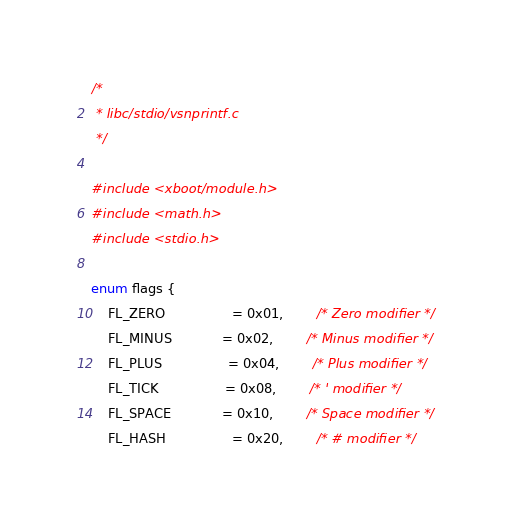<code> <loc_0><loc_0><loc_500><loc_500><_C_>/*
 * libc/stdio/vsnprintf.c
 */

#include <xboot/module.h>
#include <math.h>
#include <stdio.h>

enum flags {
	FL_ZERO				= 0x01,		/* Zero modifier */
	FL_MINUS			= 0x02,		/* Minus modifier */
	FL_PLUS				= 0x04,		/* Plus modifier */
	FL_TICK				= 0x08,		/* ' modifier */
	FL_SPACE			= 0x10,		/* Space modifier */
	FL_HASH				= 0x20,		/* # modifier */</code> 